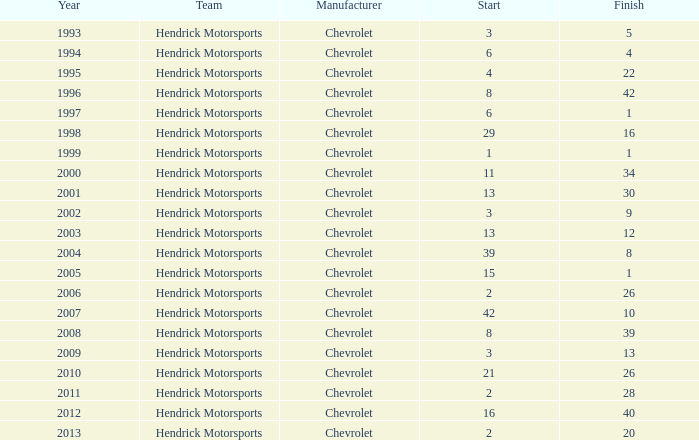What is the quantity of completions with a beginning of 15? 1.0. 